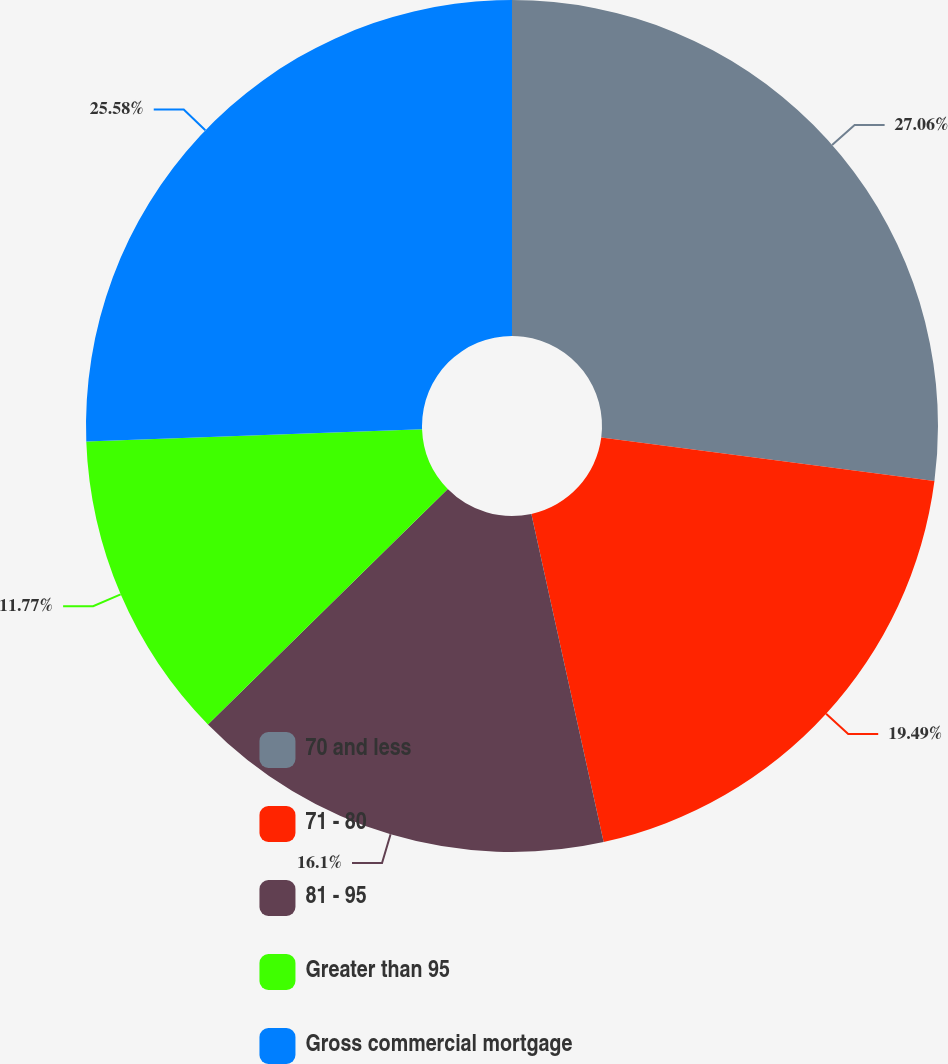<chart> <loc_0><loc_0><loc_500><loc_500><pie_chart><fcel>70 and less<fcel>71 - 80<fcel>81 - 95<fcel>Greater than 95<fcel>Gross commercial mortgage<nl><fcel>27.06%<fcel>19.49%<fcel>16.1%<fcel>11.77%<fcel>25.58%<nl></chart> 